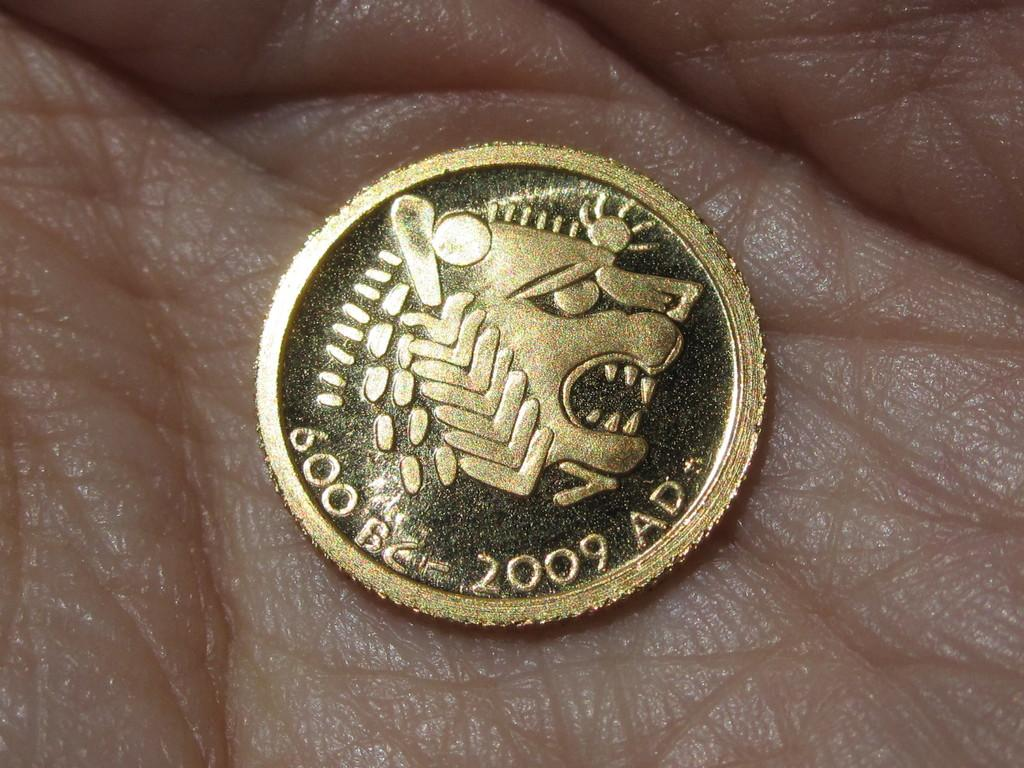<image>
Write a terse but informative summary of the picture. a coin with 2009 ad written on the front 